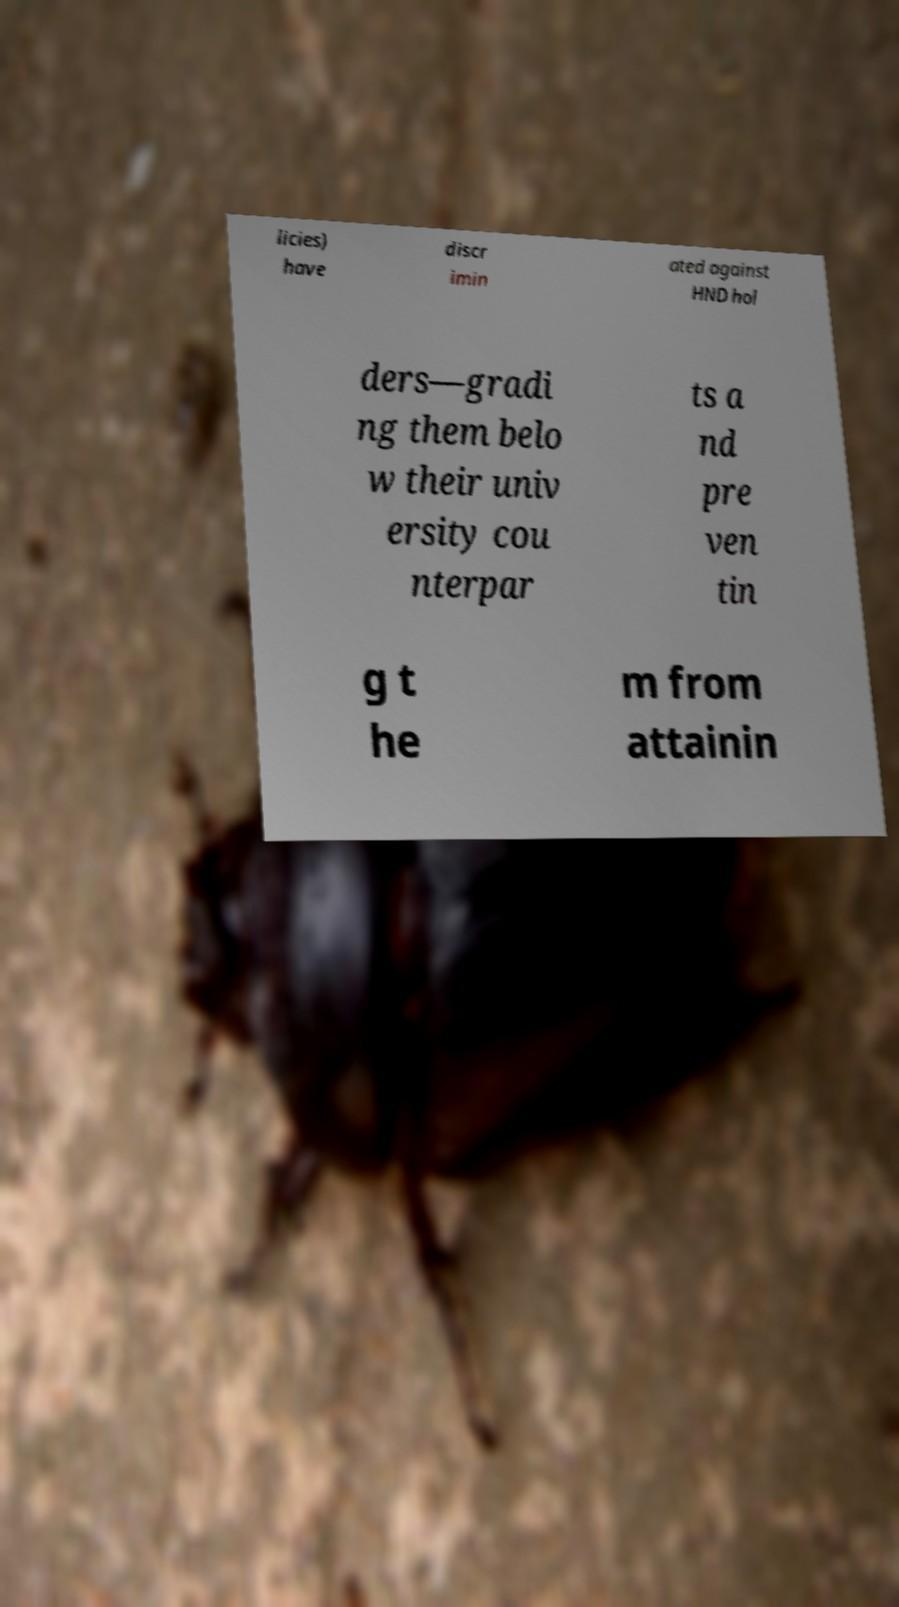Could you extract and type out the text from this image? licies) have discr imin ated against HND hol ders—gradi ng them belo w their univ ersity cou nterpar ts a nd pre ven tin g t he m from attainin 